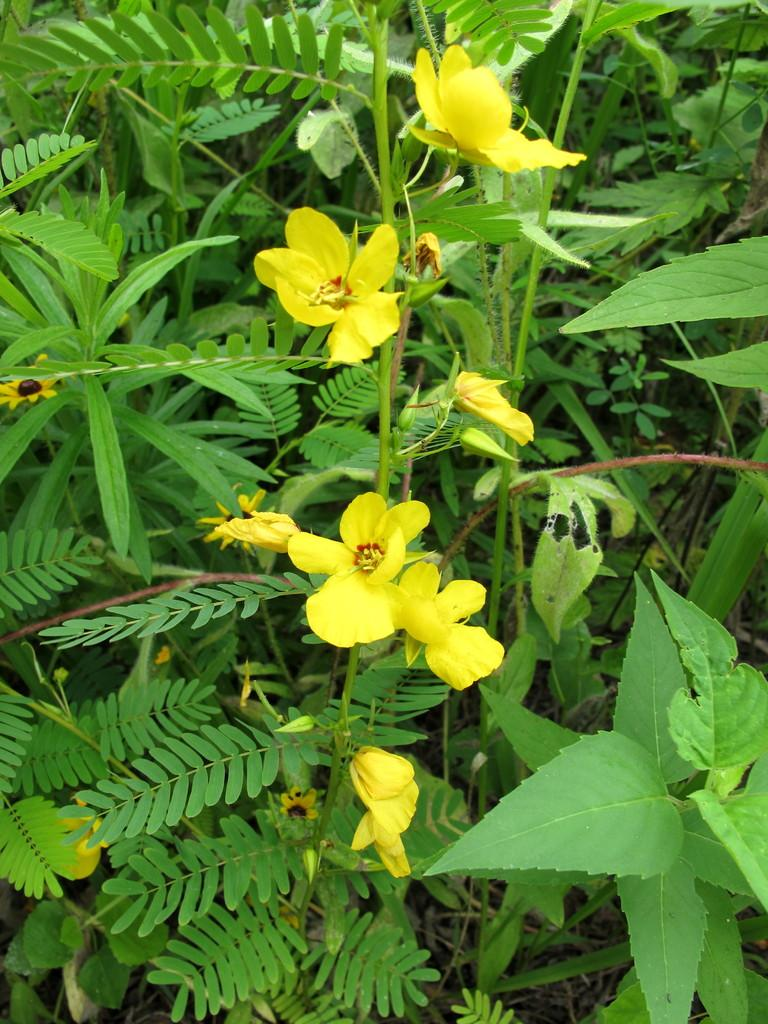What type of living organisms can be seen in the image? Plants and flowers can be seen in the image. Can you describe the flowers in the image? The flowers in the image are part of the plants. What type of transportation can be seen at the end of the image? There is no transportation visible in the image; it only features plants and flowers. Is there a note attached to any of the plants in the image? There is no note present in the image. 